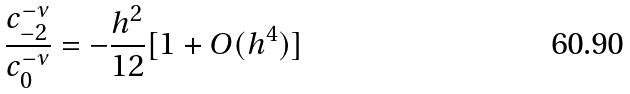Convert formula to latex. <formula><loc_0><loc_0><loc_500><loc_500>\frac { c _ { - 2 } ^ { - \nu } } { c _ { 0 } ^ { - \nu } } = - \frac { h ^ { 2 } } { 1 2 } [ 1 + O ( h ^ { 4 } ) ]</formula> 